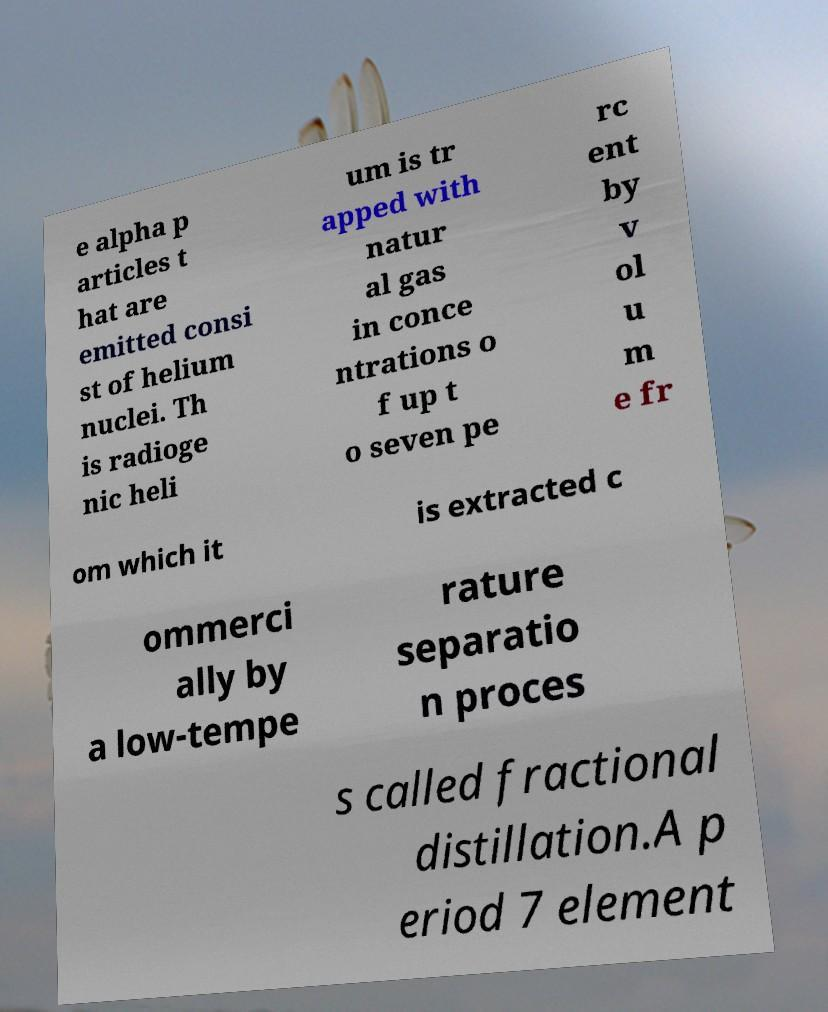Can you accurately transcribe the text from the provided image for me? e alpha p articles t hat are emitted consi st of helium nuclei. Th is radioge nic heli um is tr apped with natur al gas in conce ntrations o f up t o seven pe rc ent by v ol u m e fr om which it is extracted c ommerci ally by a low-tempe rature separatio n proces s called fractional distillation.A p eriod 7 element 